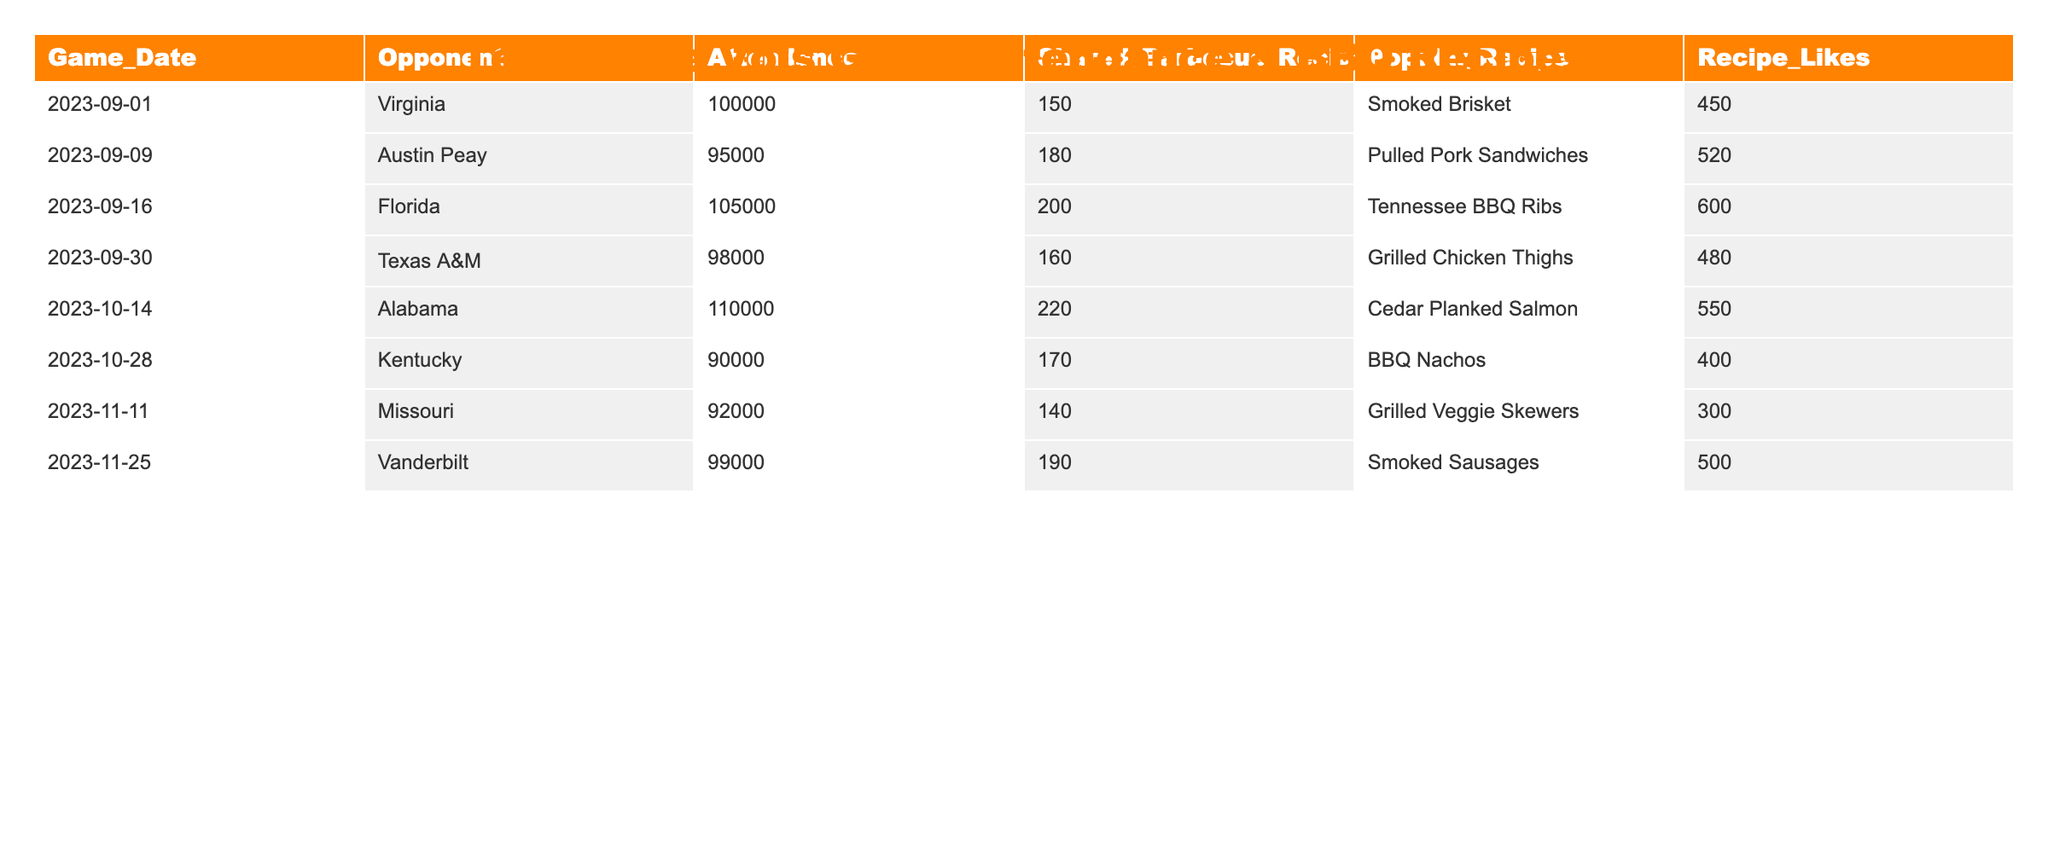What was the highest game attendance? The table shows "110000" as the attendance at the Alabama game on 2023-10-14, which is greater than any other game's attendance.
Answer: 110000 Which popular recipe had the most likes? The table indicates that "Tennessee BBQ Ribs" received the most likes at "600", which is higher than all other recipes listed.
Answer: 600 How many barbecue recipes were shared for the game against Virginia? The table lists "150" as the number of shared barbecue recipes for the Virginia game on 2023-09-01.
Answer: 150 What is the average attendance across all games? The sum of all attendances is 100000 + 95000 + 105000 + 98000 + 110000 + 90000 + 92000 + 99000 =  836000. There are 8 games, so the average attendance is 836000 / 8 = 104500.
Answer: 104500 Did the Kentucky game have more or fewer shared barbecue recipes than the Alabama game? The table shows "170" recipes shared for Kentucky and "220" for Alabama, thus Kentucky had fewer.
Answer: Fewer What is the difference in shared barbecue recipes between the Florida and Vanderbilt games? The table lists "200" for Florida and "190" for Vanderbilt. The difference is calculated as 200 - 190 = 10.
Answer: 10 Which game had the least attendance and how many barbecue recipes were shared for that game? The least attendance was "90000" at the Kentucky game on 2023-10-28, with "170" barbecue recipes shared.
Answer: 90000; 170 How many more likes did the "Cedar Planked Salmon" recipe receive compared to the "BBQ Nachos" recipe? "Cedar Planked Salmon" received "550" likes while "BBQ Nachos" received "400". The difference is 550 - 400 = 150.
Answer: 150 What is the total number of barbecue recipes shared for all games combined? The total is the sum of shared recipes: 150 + 180 + 200 + 160 + 220 + 170 + 140 + 190 = 1310.
Answer: 1310 Is there a game where the number of shared barbecue recipes is exactly double the attendance? By checking each game, none show an exact ratio of recipes to double the attendance. Therefore, the answer is no.
Answer: No 